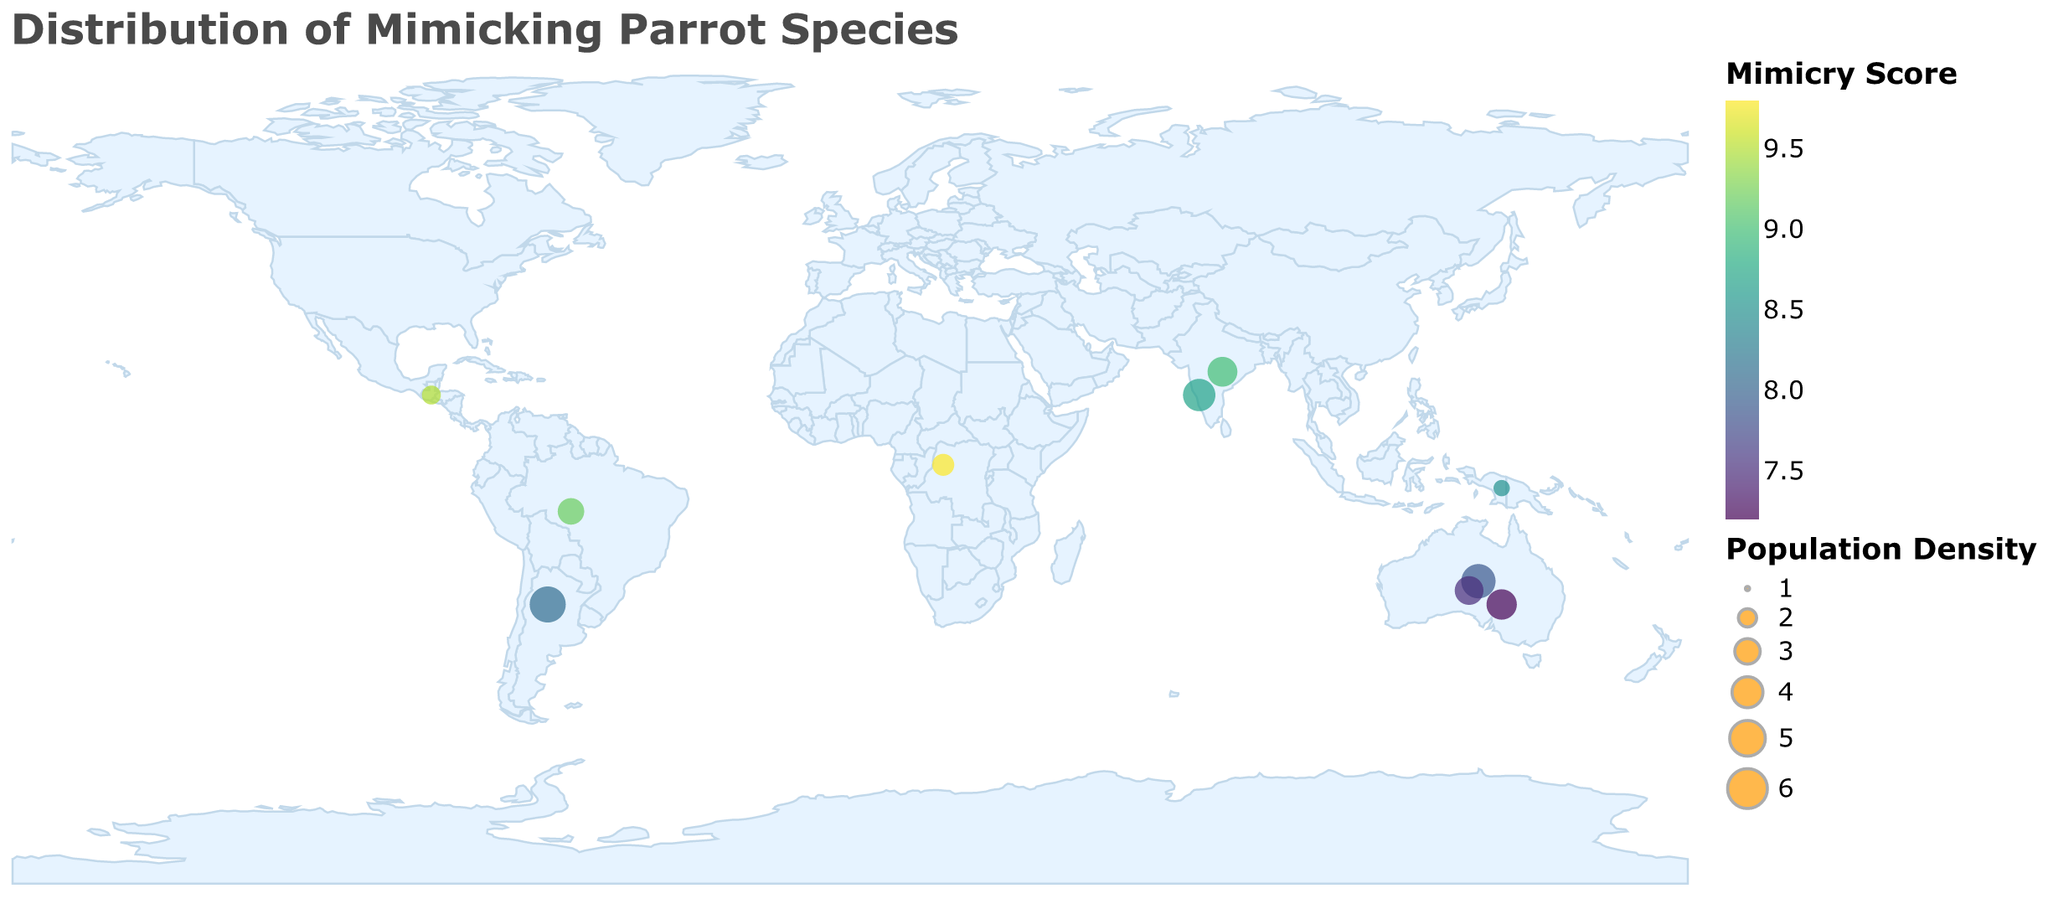What is the title of the geographic plot? The title is written at the top of the plot.
Answer: Distribution of Mimicking Parrot Species How many parrot species are shown in the plot? Each circle on the plot represents one of the parrot species listed.
Answer: 10 Which parrot species has the highest population density? The size of the circle corresponds to the population density; the largest circle represents the species with the highest density.
Answer: Monk Parakeet Which region has the parrot species with the highest mimicry score? Mimicry scores are displayed as colors on the circles; the highest score is the darkest color on the viridis color scale. The region can be identified by the corresponding circle.
Answer: Central Africa (African Grey Parrot) Compare the mimicry scores of the African Grey Parrot and Amazon Parrot. Which one is higher? The African Grey Parrot and Amazon Parrot scores can be compared by their color intensity on the plot. The darkest color represents the higher mimicry score.
Answer: African Grey Parrot Which parrot species in Australia has the highest mimicry score? There are several species from Australia displayed; examining the colors of their corresponding circles will indicate the one with the highest mimicry score.
Answer: Budgerigar Calculate the average population density of parrot species in South America. Summing the population densities of parrot species in South America (Amazon Parrot and Monk Parakeet) and dividing by the number of species will yield the average. (3.2 + 5.1) / 2 = 4.15
Answer: 4.15 What is the difference in mimicry scores between the Yellow-naped Amazon and the Indian Ringneck? Subtract the mimicry score of the Indian Ringneck from that of the Yellow-naped Amazon. 9.5 - 9.0 = 0.5
Answer: 0.5 Which region has the most parrot species listed in the plot? Count the circles based on the regions mentioned: Central Africa, Southeast Asia and Oceania, South America, Australia, South Asia, and Africa, and Central America.
Answer: Australia Identify the species with lower population density but higher mimicry score, compared to the Eclectus Parrot. Compare both population density and mimicry score of the species against those of Eclectus Parrot (Population Density: 1.8, Mimicry Score: 8.5) looking for lower population density and higher mimicry score.
Answer: Yellow-naped Amazon 